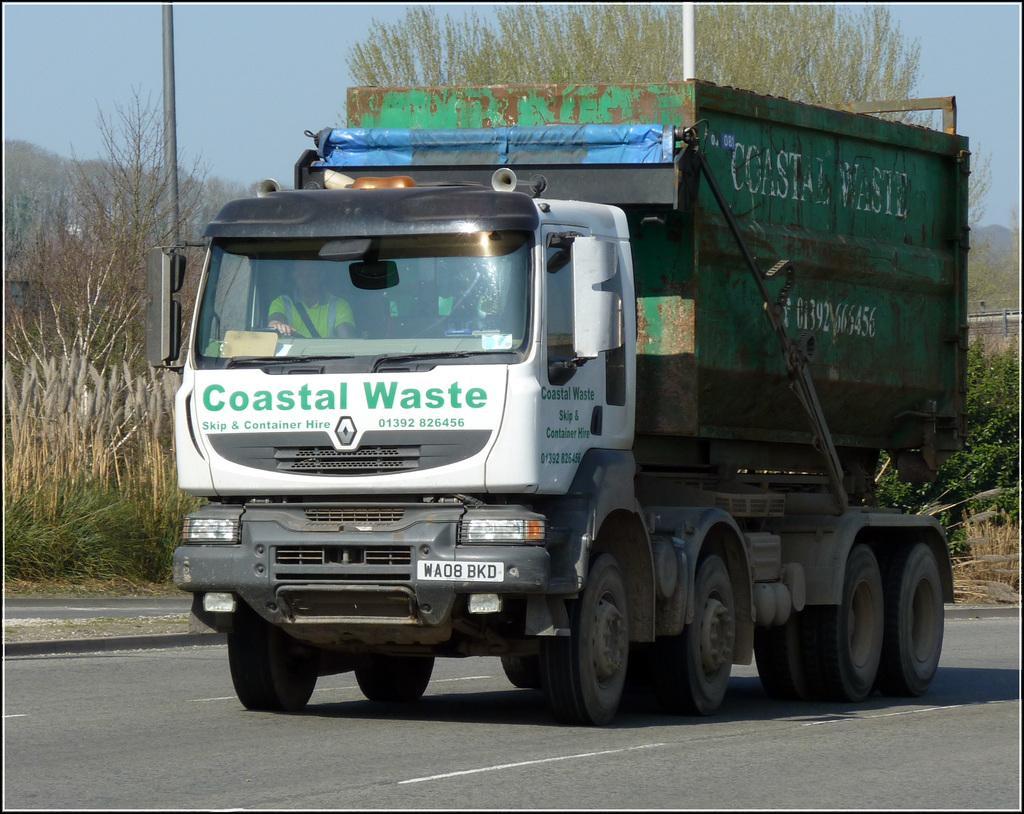In one or two sentences, can you explain what this image depicts? In this image I can see a truck which is white, green, blue and black in color is on the road. In the background I can see few trees, a metal pole and the sky. 